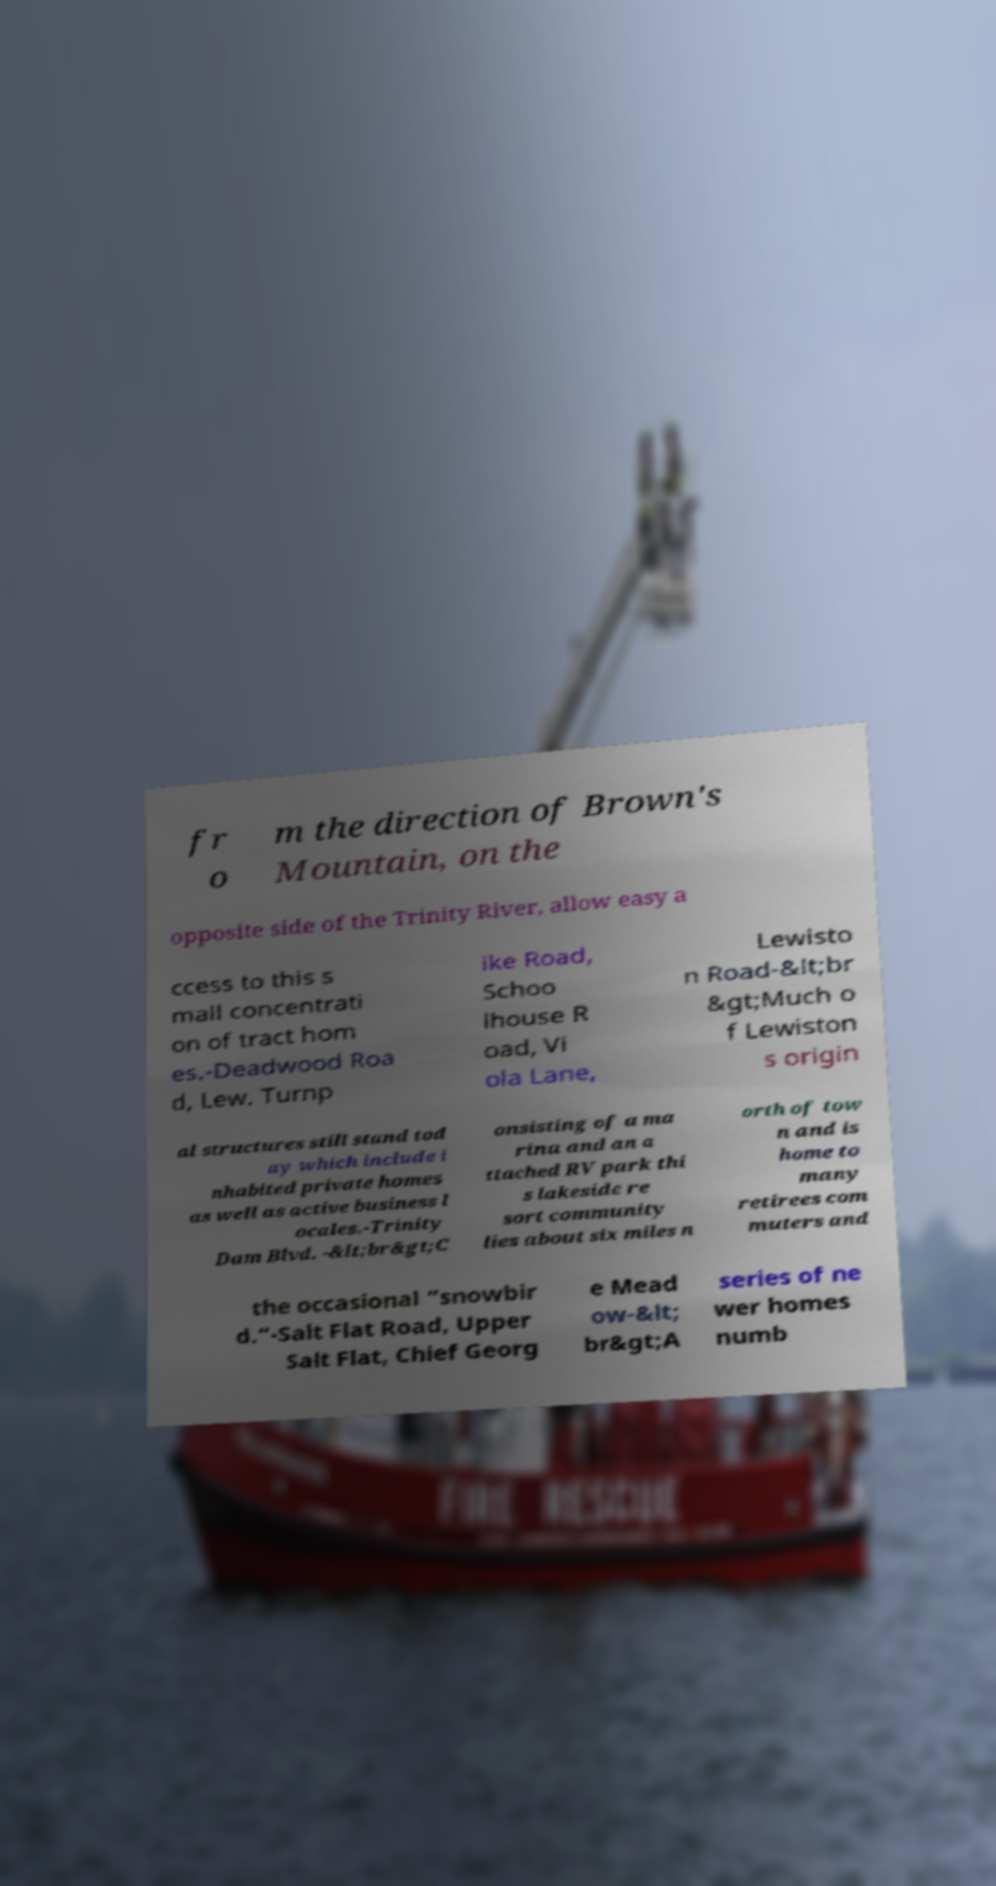I need the written content from this picture converted into text. Can you do that? fr o m the direction of Brown's Mountain, on the opposite side of the Trinity River, allow easy a ccess to this s mall concentrati on of tract hom es.-Deadwood Roa d, Lew. Turnp ike Road, Schoo lhouse R oad, Vi ola Lane, Lewisto n Road-&lt;br &gt;Much o f Lewiston s origin al structures still stand tod ay which include i nhabited private homes as well as active business l ocales.-Trinity Dam Blvd. -&lt;br&gt;C onsisting of a ma rina and an a ttached RV park thi s lakeside re sort community lies about six miles n orth of tow n and is home to many retirees com muters and the occasional “snowbir d.”-Salt Flat Road, Upper Salt Flat, Chief Georg e Mead ow-&lt; br&gt;A series of ne wer homes numb 